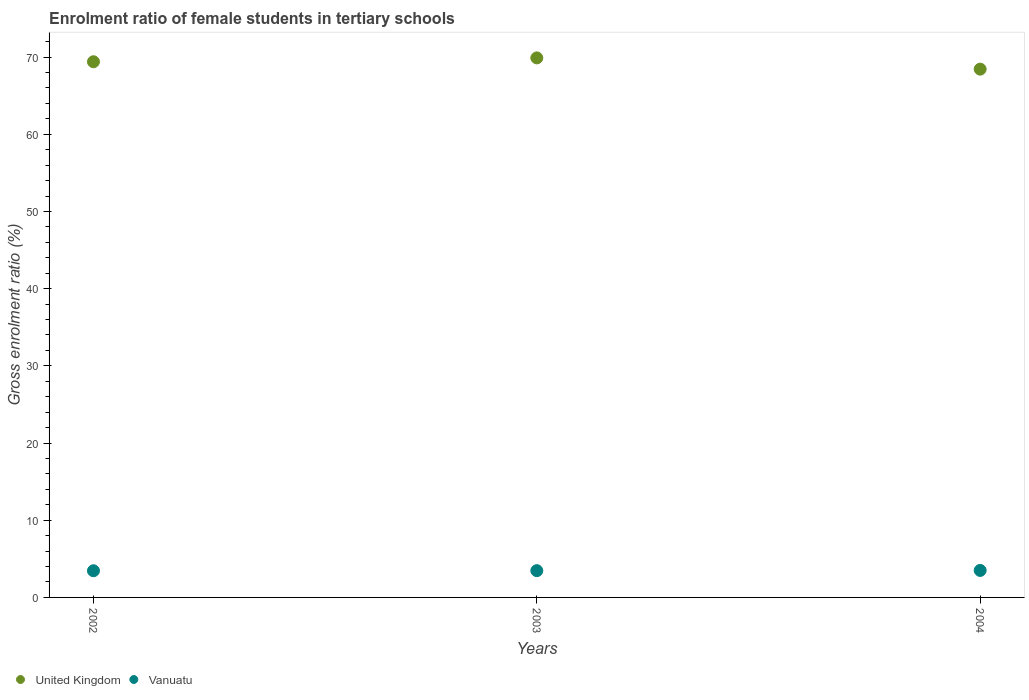What is the enrolment ratio of female students in tertiary schools in Vanuatu in 2003?
Your response must be concise. 3.47. Across all years, what is the maximum enrolment ratio of female students in tertiary schools in Vanuatu?
Offer a very short reply. 3.5. Across all years, what is the minimum enrolment ratio of female students in tertiary schools in United Kingdom?
Provide a short and direct response. 68.44. What is the total enrolment ratio of female students in tertiary schools in United Kingdom in the graph?
Offer a very short reply. 207.73. What is the difference between the enrolment ratio of female students in tertiary schools in United Kingdom in 2002 and that in 2003?
Make the answer very short. -0.5. What is the difference between the enrolment ratio of female students in tertiary schools in United Kingdom in 2004 and the enrolment ratio of female students in tertiary schools in Vanuatu in 2003?
Offer a terse response. 64.97. What is the average enrolment ratio of female students in tertiary schools in United Kingdom per year?
Provide a short and direct response. 69.24. In the year 2004, what is the difference between the enrolment ratio of female students in tertiary schools in Vanuatu and enrolment ratio of female students in tertiary schools in United Kingdom?
Give a very brief answer. -64.94. In how many years, is the enrolment ratio of female students in tertiary schools in Vanuatu greater than 44 %?
Your answer should be compact. 0. What is the ratio of the enrolment ratio of female students in tertiary schools in Vanuatu in 2002 to that in 2004?
Your answer should be very brief. 0.99. What is the difference between the highest and the second highest enrolment ratio of female students in tertiary schools in United Kingdom?
Your answer should be compact. 0.5. What is the difference between the highest and the lowest enrolment ratio of female students in tertiary schools in Vanuatu?
Offer a very short reply. 0.04. In how many years, is the enrolment ratio of female students in tertiary schools in United Kingdom greater than the average enrolment ratio of female students in tertiary schools in United Kingdom taken over all years?
Ensure brevity in your answer.  2. Does the enrolment ratio of female students in tertiary schools in Vanuatu monotonically increase over the years?
Offer a terse response. Yes. Is the enrolment ratio of female students in tertiary schools in United Kingdom strictly greater than the enrolment ratio of female students in tertiary schools in Vanuatu over the years?
Provide a succinct answer. Yes. Is the enrolment ratio of female students in tertiary schools in United Kingdom strictly less than the enrolment ratio of female students in tertiary schools in Vanuatu over the years?
Your answer should be compact. No. How many years are there in the graph?
Give a very brief answer. 3. What is the difference between two consecutive major ticks on the Y-axis?
Keep it short and to the point. 10. Are the values on the major ticks of Y-axis written in scientific E-notation?
Make the answer very short. No. Does the graph contain any zero values?
Offer a very short reply. No. Where does the legend appear in the graph?
Keep it short and to the point. Bottom left. How many legend labels are there?
Make the answer very short. 2. What is the title of the graph?
Keep it short and to the point. Enrolment ratio of female students in tertiary schools. What is the label or title of the X-axis?
Your answer should be very brief. Years. What is the Gross enrolment ratio (%) in United Kingdom in 2002?
Ensure brevity in your answer.  69.4. What is the Gross enrolment ratio (%) in Vanuatu in 2002?
Your answer should be very brief. 3.46. What is the Gross enrolment ratio (%) in United Kingdom in 2003?
Offer a very short reply. 69.9. What is the Gross enrolment ratio (%) in Vanuatu in 2003?
Provide a succinct answer. 3.47. What is the Gross enrolment ratio (%) of United Kingdom in 2004?
Your answer should be very brief. 68.44. What is the Gross enrolment ratio (%) in Vanuatu in 2004?
Offer a very short reply. 3.5. Across all years, what is the maximum Gross enrolment ratio (%) of United Kingdom?
Your answer should be compact. 69.9. Across all years, what is the maximum Gross enrolment ratio (%) of Vanuatu?
Provide a succinct answer. 3.5. Across all years, what is the minimum Gross enrolment ratio (%) of United Kingdom?
Your answer should be compact. 68.44. Across all years, what is the minimum Gross enrolment ratio (%) in Vanuatu?
Provide a short and direct response. 3.46. What is the total Gross enrolment ratio (%) of United Kingdom in the graph?
Your response must be concise. 207.73. What is the total Gross enrolment ratio (%) in Vanuatu in the graph?
Your response must be concise. 10.42. What is the difference between the Gross enrolment ratio (%) in United Kingdom in 2002 and that in 2003?
Provide a succinct answer. -0.5. What is the difference between the Gross enrolment ratio (%) in Vanuatu in 2002 and that in 2003?
Your response must be concise. -0.01. What is the difference between the Gross enrolment ratio (%) of United Kingdom in 2002 and that in 2004?
Ensure brevity in your answer.  0.96. What is the difference between the Gross enrolment ratio (%) in Vanuatu in 2002 and that in 2004?
Keep it short and to the point. -0.04. What is the difference between the Gross enrolment ratio (%) in United Kingdom in 2003 and that in 2004?
Your answer should be very brief. 1.46. What is the difference between the Gross enrolment ratio (%) of Vanuatu in 2003 and that in 2004?
Your response must be concise. -0.03. What is the difference between the Gross enrolment ratio (%) in United Kingdom in 2002 and the Gross enrolment ratio (%) in Vanuatu in 2003?
Give a very brief answer. 65.93. What is the difference between the Gross enrolment ratio (%) of United Kingdom in 2002 and the Gross enrolment ratio (%) of Vanuatu in 2004?
Your response must be concise. 65.9. What is the difference between the Gross enrolment ratio (%) of United Kingdom in 2003 and the Gross enrolment ratio (%) of Vanuatu in 2004?
Make the answer very short. 66.4. What is the average Gross enrolment ratio (%) of United Kingdom per year?
Provide a succinct answer. 69.24. What is the average Gross enrolment ratio (%) in Vanuatu per year?
Offer a very short reply. 3.47. In the year 2002, what is the difference between the Gross enrolment ratio (%) of United Kingdom and Gross enrolment ratio (%) of Vanuatu?
Your response must be concise. 65.94. In the year 2003, what is the difference between the Gross enrolment ratio (%) in United Kingdom and Gross enrolment ratio (%) in Vanuatu?
Provide a short and direct response. 66.43. In the year 2004, what is the difference between the Gross enrolment ratio (%) of United Kingdom and Gross enrolment ratio (%) of Vanuatu?
Offer a terse response. 64.94. What is the ratio of the Gross enrolment ratio (%) in Vanuatu in 2002 to that in 2004?
Provide a short and direct response. 0.99. What is the ratio of the Gross enrolment ratio (%) of United Kingdom in 2003 to that in 2004?
Your answer should be compact. 1.02. What is the difference between the highest and the second highest Gross enrolment ratio (%) in United Kingdom?
Offer a very short reply. 0.5. What is the difference between the highest and the second highest Gross enrolment ratio (%) of Vanuatu?
Offer a terse response. 0.03. What is the difference between the highest and the lowest Gross enrolment ratio (%) of United Kingdom?
Ensure brevity in your answer.  1.46. What is the difference between the highest and the lowest Gross enrolment ratio (%) of Vanuatu?
Offer a very short reply. 0.04. 